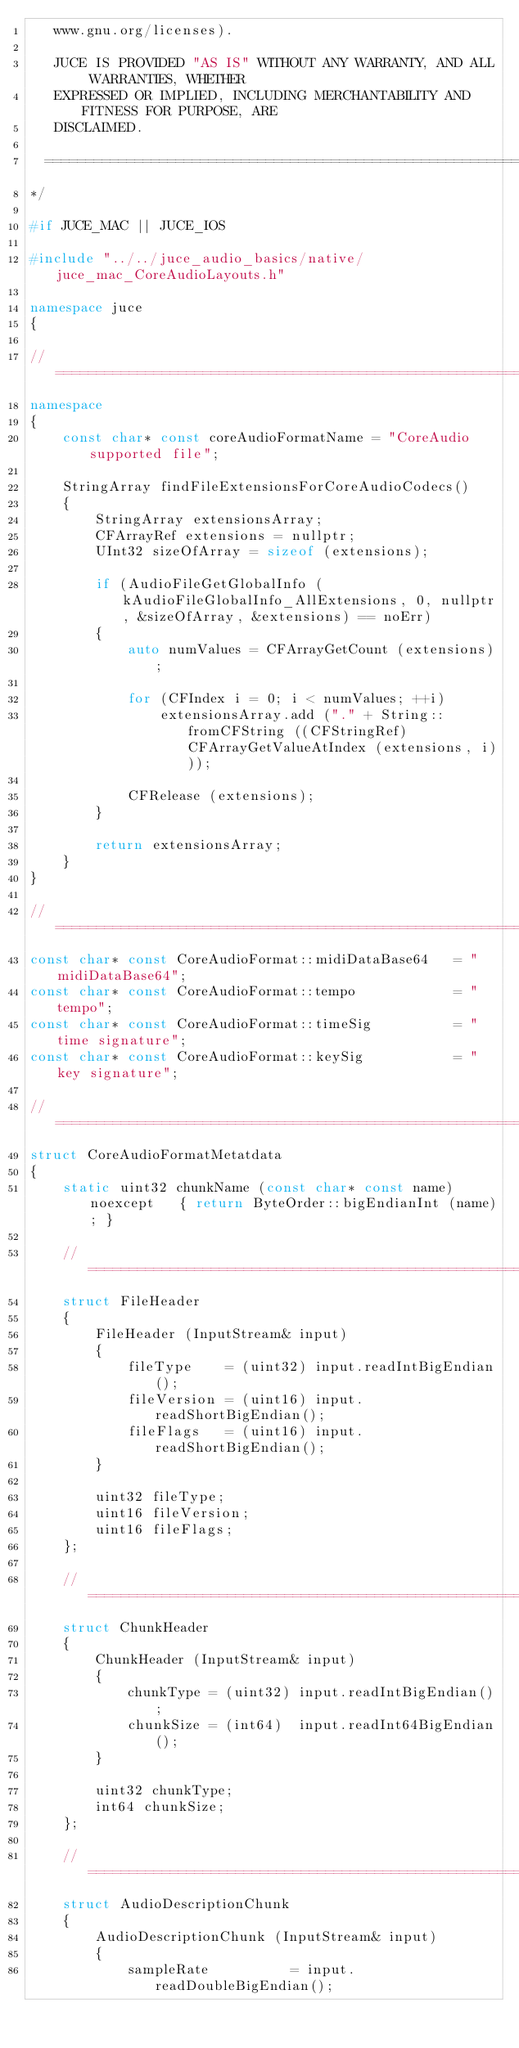Convert code to text. <code><loc_0><loc_0><loc_500><loc_500><_C++_>   www.gnu.org/licenses).

   JUCE IS PROVIDED "AS IS" WITHOUT ANY WARRANTY, AND ALL WARRANTIES, WHETHER
   EXPRESSED OR IMPLIED, INCLUDING MERCHANTABILITY AND FITNESS FOR PURPOSE, ARE
   DISCLAIMED.

  ==============================================================================
*/

#if JUCE_MAC || JUCE_IOS

#include "../../juce_audio_basics/native/juce_mac_CoreAudioLayouts.h"

namespace juce
{

//==============================================================================
namespace
{
    const char* const coreAudioFormatName = "CoreAudio supported file";

    StringArray findFileExtensionsForCoreAudioCodecs()
    {
        StringArray extensionsArray;
        CFArrayRef extensions = nullptr;
        UInt32 sizeOfArray = sizeof (extensions);

        if (AudioFileGetGlobalInfo (kAudioFileGlobalInfo_AllExtensions, 0, nullptr, &sizeOfArray, &extensions) == noErr)
        {
            auto numValues = CFArrayGetCount (extensions);

            for (CFIndex i = 0; i < numValues; ++i)
                extensionsArray.add ("." + String::fromCFString ((CFStringRef) CFArrayGetValueAtIndex (extensions, i)));

            CFRelease (extensions);
        }

        return extensionsArray;
    }
}

//==============================================================================
const char* const CoreAudioFormat::midiDataBase64   = "midiDataBase64";
const char* const CoreAudioFormat::tempo            = "tempo";
const char* const CoreAudioFormat::timeSig          = "time signature";
const char* const CoreAudioFormat::keySig           = "key signature";

//==============================================================================
struct CoreAudioFormatMetatdata
{
    static uint32 chunkName (const char* const name) noexcept   { return ByteOrder::bigEndianInt (name); }

    //==============================================================================
    struct FileHeader
    {
        FileHeader (InputStream& input)
        {
            fileType    = (uint32) input.readIntBigEndian();
            fileVersion = (uint16) input.readShortBigEndian();
            fileFlags   = (uint16) input.readShortBigEndian();
        }

        uint32 fileType;
        uint16 fileVersion;
        uint16 fileFlags;
    };

    //==============================================================================
    struct ChunkHeader
    {
        ChunkHeader (InputStream& input)
        {
            chunkType = (uint32) input.readIntBigEndian();
            chunkSize = (int64)  input.readInt64BigEndian();
        }

        uint32 chunkType;
        int64 chunkSize;
    };

    //==============================================================================
    struct AudioDescriptionChunk
    {
        AudioDescriptionChunk (InputStream& input)
        {
            sampleRate          = input.readDoubleBigEndian();</code> 